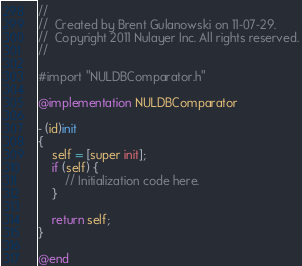<code> <loc_0><loc_0><loc_500><loc_500><_ObjectiveC_>//
//  Created by Brent Gulanowski on 11-07-29.
//  Copyright 2011 Nulayer Inc. All rights reserved.
//

#import "NULDBComparator.h"

@implementation NULDBComparator

- (id)init
{
    self = [super init];
    if (self) {
        // Initialization code here.
    }
    
    return self;
}

@end
</code> 